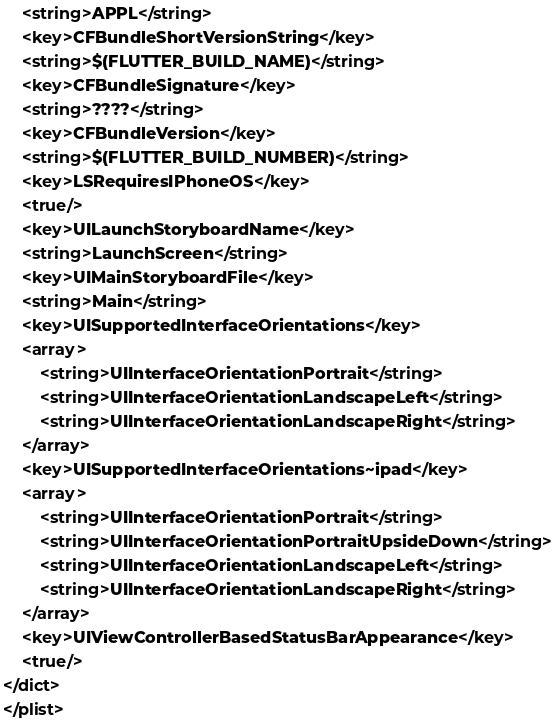<code> <loc_0><loc_0><loc_500><loc_500><_XML_>	<string>APPL</string>
	<key>CFBundleShortVersionString</key>
	<string>$(FLUTTER_BUILD_NAME)</string>
	<key>CFBundleSignature</key>
	<string>????</string>
	<key>CFBundleVersion</key>
	<string>$(FLUTTER_BUILD_NUMBER)</string>
	<key>LSRequiresIPhoneOS</key>
	<true/>
	<key>UILaunchStoryboardName</key>
	<string>LaunchScreen</string>
	<key>UIMainStoryboardFile</key>
	<string>Main</string>
	<key>UISupportedInterfaceOrientations</key>
	<array>
		<string>UIInterfaceOrientationPortrait</string>
		<string>UIInterfaceOrientationLandscapeLeft</string>
		<string>UIInterfaceOrientationLandscapeRight</string>
	</array>
	<key>UISupportedInterfaceOrientations~ipad</key>
	<array>
		<string>UIInterfaceOrientationPortrait</string>
		<string>UIInterfaceOrientationPortraitUpsideDown</string>
		<string>UIInterfaceOrientationLandscapeLeft</string>
		<string>UIInterfaceOrientationLandscapeRight</string>
	</array>
	<key>UIViewControllerBasedStatusBarAppearance</key>
	<true/>
</dict>
</plist>
</code> 